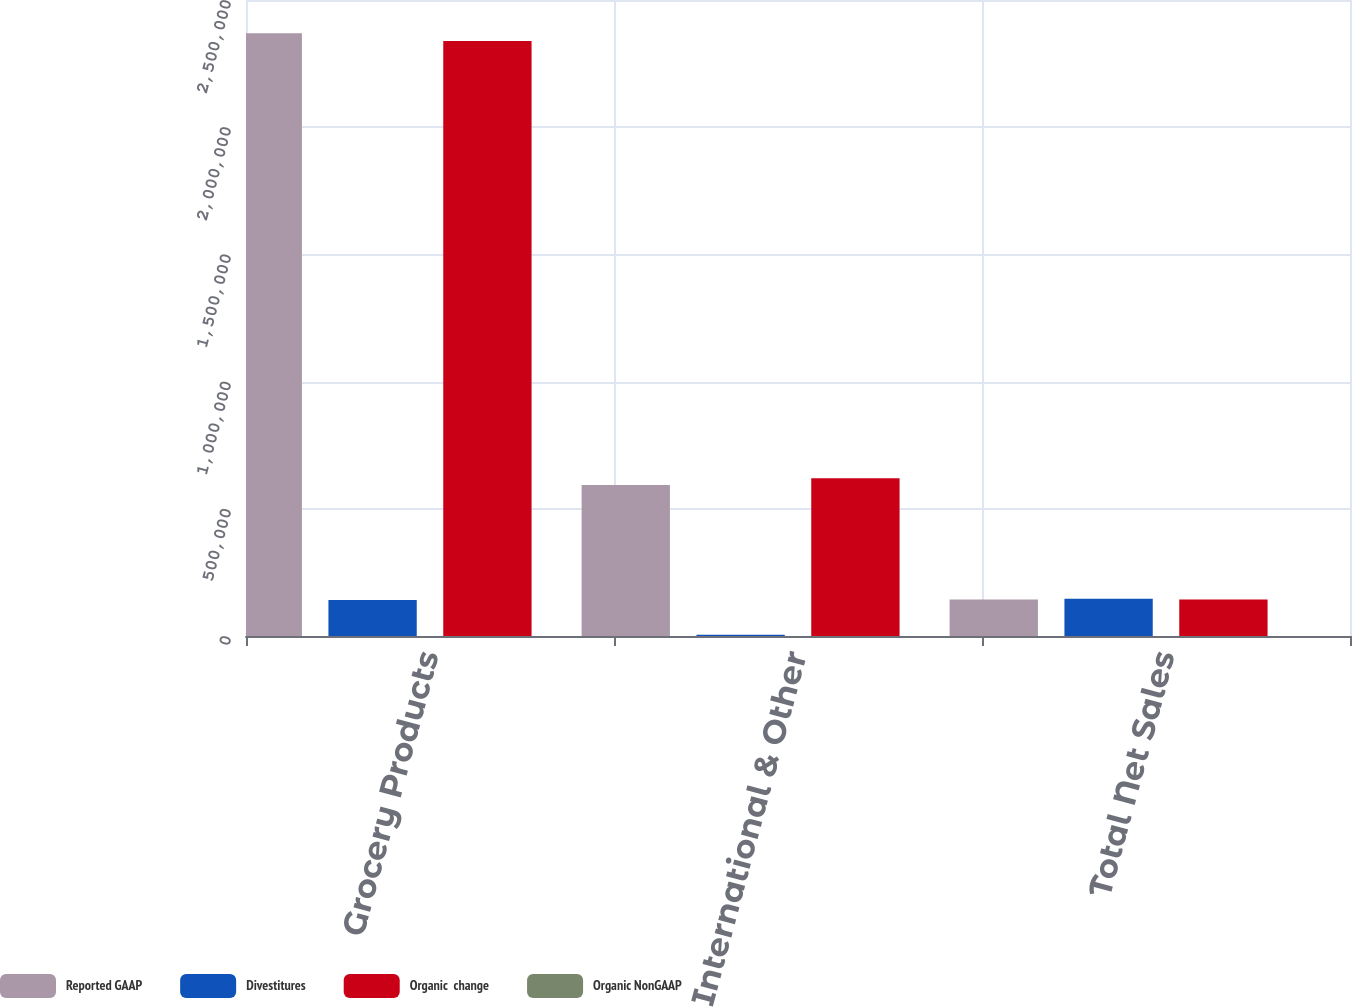<chart> <loc_0><loc_0><loc_500><loc_500><stacked_bar_chart><ecel><fcel>Grocery Products<fcel>International & Other<fcel>Total Net Sales<nl><fcel>Reported GAAP<fcel>2.36932e+06<fcel>593476<fcel>143749<nl><fcel>Divestitures<fcel>141401<fcel>4696<fcel>146097<nl><fcel>Organic  change<fcel>2.33897e+06<fcel>619743<fcel>143749<nl><fcel>Organic NonGAAP<fcel>1.3<fcel>4.2<fcel>1<nl></chart> 